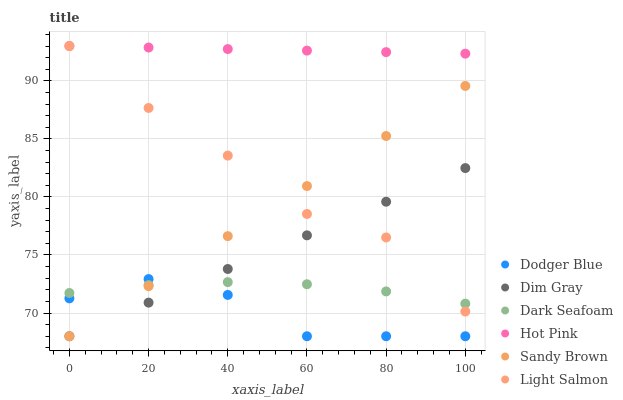Does Dodger Blue have the minimum area under the curve?
Answer yes or no. Yes. Does Hot Pink have the maximum area under the curve?
Answer yes or no. Yes. Does Dim Gray have the minimum area under the curve?
Answer yes or no. No. Does Dim Gray have the maximum area under the curve?
Answer yes or no. No. Is Dim Gray the smoothest?
Answer yes or no. Yes. Is Light Salmon the roughest?
Answer yes or no. Yes. Is Hot Pink the smoothest?
Answer yes or no. No. Is Hot Pink the roughest?
Answer yes or no. No. Does Dim Gray have the lowest value?
Answer yes or no. Yes. Does Hot Pink have the lowest value?
Answer yes or no. No. Does Hot Pink have the highest value?
Answer yes or no. Yes. Does Dim Gray have the highest value?
Answer yes or no. No. Is Dodger Blue less than Light Salmon?
Answer yes or no. Yes. Is Light Salmon greater than Dodger Blue?
Answer yes or no. Yes. Does Dodger Blue intersect Dark Seafoam?
Answer yes or no. Yes. Is Dodger Blue less than Dark Seafoam?
Answer yes or no. No. Is Dodger Blue greater than Dark Seafoam?
Answer yes or no. No. Does Dodger Blue intersect Light Salmon?
Answer yes or no. No. 